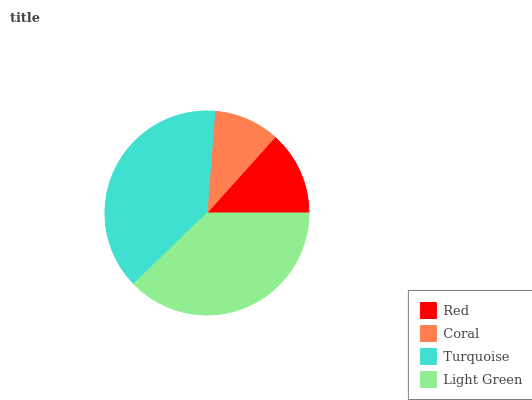Is Coral the minimum?
Answer yes or no. Yes. Is Turquoise the maximum?
Answer yes or no. Yes. Is Turquoise the minimum?
Answer yes or no. No. Is Coral the maximum?
Answer yes or no. No. Is Turquoise greater than Coral?
Answer yes or no. Yes. Is Coral less than Turquoise?
Answer yes or no. Yes. Is Coral greater than Turquoise?
Answer yes or no. No. Is Turquoise less than Coral?
Answer yes or no. No. Is Light Green the high median?
Answer yes or no. Yes. Is Red the low median?
Answer yes or no. Yes. Is Turquoise the high median?
Answer yes or no. No. Is Coral the low median?
Answer yes or no. No. 